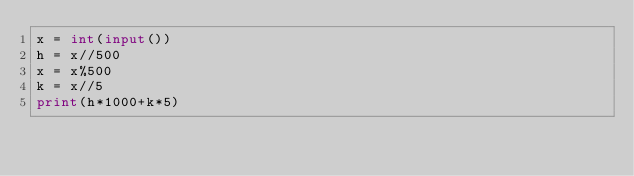<code> <loc_0><loc_0><loc_500><loc_500><_Python_>x = int(input())
h = x//500
x = x%500
k = x//5
print(h*1000+k*5)</code> 